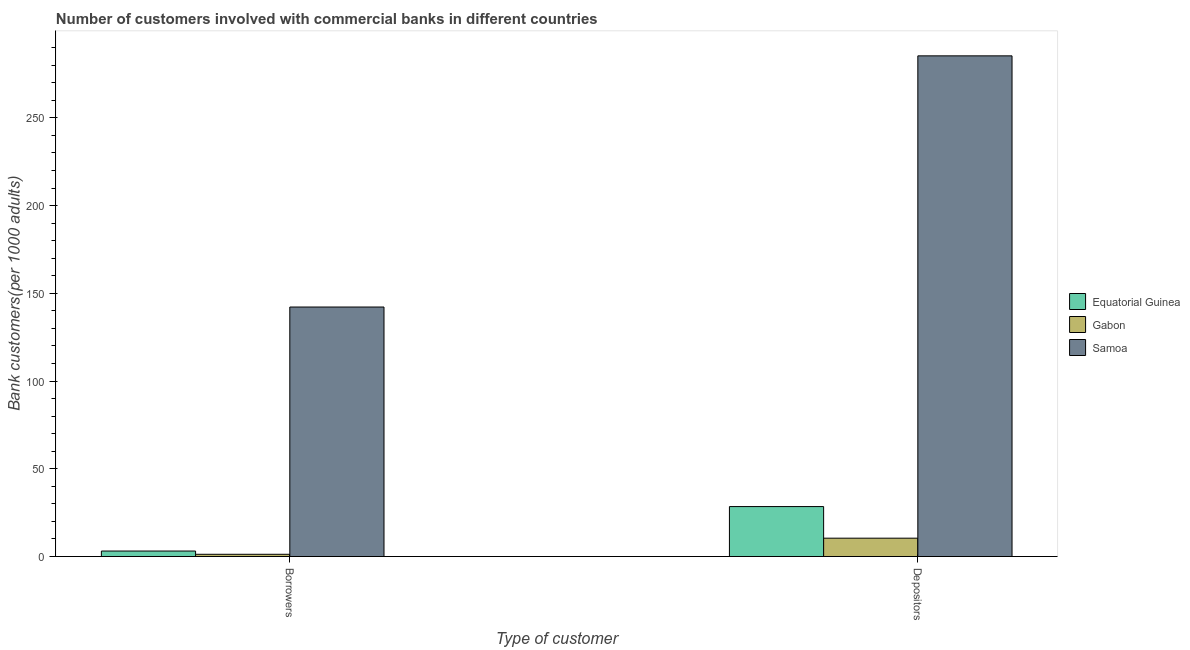Are the number of bars per tick equal to the number of legend labels?
Make the answer very short. Yes. How many bars are there on the 2nd tick from the right?
Your answer should be compact. 3. What is the label of the 1st group of bars from the left?
Ensure brevity in your answer.  Borrowers. What is the number of borrowers in Gabon?
Provide a succinct answer. 1.28. Across all countries, what is the maximum number of borrowers?
Your response must be concise. 142.19. Across all countries, what is the minimum number of borrowers?
Offer a very short reply. 1.28. In which country was the number of depositors maximum?
Your answer should be very brief. Samoa. In which country was the number of depositors minimum?
Offer a very short reply. Gabon. What is the total number of depositors in the graph?
Give a very brief answer. 324.25. What is the difference between the number of depositors in Equatorial Guinea and that in Samoa?
Make the answer very short. -256.85. What is the difference between the number of depositors in Gabon and the number of borrowers in Samoa?
Provide a succinct answer. -131.73. What is the average number of depositors per country?
Your answer should be very brief. 108.08. What is the difference between the number of borrowers and number of depositors in Samoa?
Your response must be concise. -143.13. What is the ratio of the number of depositors in Equatorial Guinea to that in Samoa?
Your response must be concise. 0.1. Is the number of borrowers in Gabon less than that in Samoa?
Offer a very short reply. Yes. What does the 1st bar from the left in Depositors represents?
Offer a very short reply. Equatorial Guinea. What does the 2nd bar from the right in Borrowers represents?
Offer a terse response. Gabon. How many bars are there?
Give a very brief answer. 6. Are all the bars in the graph horizontal?
Offer a terse response. No. How many countries are there in the graph?
Provide a short and direct response. 3. Are the values on the major ticks of Y-axis written in scientific E-notation?
Offer a very short reply. No. Does the graph contain any zero values?
Offer a terse response. No. Does the graph contain grids?
Keep it short and to the point. No. How many legend labels are there?
Keep it short and to the point. 3. How are the legend labels stacked?
Offer a very short reply. Vertical. What is the title of the graph?
Keep it short and to the point. Number of customers involved with commercial banks in different countries. What is the label or title of the X-axis?
Give a very brief answer. Type of customer. What is the label or title of the Y-axis?
Provide a succinct answer. Bank customers(per 1000 adults). What is the Bank customers(per 1000 adults) in Equatorial Guinea in Borrowers?
Make the answer very short. 3.13. What is the Bank customers(per 1000 adults) of Gabon in Borrowers?
Your answer should be very brief. 1.28. What is the Bank customers(per 1000 adults) in Samoa in Borrowers?
Your answer should be compact. 142.19. What is the Bank customers(per 1000 adults) in Equatorial Guinea in Depositors?
Your response must be concise. 28.47. What is the Bank customers(per 1000 adults) in Gabon in Depositors?
Give a very brief answer. 10.46. What is the Bank customers(per 1000 adults) in Samoa in Depositors?
Keep it short and to the point. 285.32. Across all Type of customer, what is the maximum Bank customers(per 1000 adults) of Equatorial Guinea?
Provide a short and direct response. 28.47. Across all Type of customer, what is the maximum Bank customers(per 1000 adults) of Gabon?
Provide a short and direct response. 10.46. Across all Type of customer, what is the maximum Bank customers(per 1000 adults) in Samoa?
Make the answer very short. 285.32. Across all Type of customer, what is the minimum Bank customers(per 1000 adults) in Equatorial Guinea?
Your answer should be very brief. 3.13. Across all Type of customer, what is the minimum Bank customers(per 1000 adults) in Gabon?
Make the answer very short. 1.28. Across all Type of customer, what is the minimum Bank customers(per 1000 adults) in Samoa?
Provide a succinct answer. 142.19. What is the total Bank customers(per 1000 adults) in Equatorial Guinea in the graph?
Offer a very short reply. 31.6. What is the total Bank customers(per 1000 adults) of Gabon in the graph?
Your answer should be very brief. 11.74. What is the total Bank customers(per 1000 adults) of Samoa in the graph?
Keep it short and to the point. 427.51. What is the difference between the Bank customers(per 1000 adults) of Equatorial Guinea in Borrowers and that in Depositors?
Offer a terse response. -25.34. What is the difference between the Bank customers(per 1000 adults) of Gabon in Borrowers and that in Depositors?
Ensure brevity in your answer.  -9.18. What is the difference between the Bank customers(per 1000 adults) of Samoa in Borrowers and that in Depositors?
Offer a terse response. -143.13. What is the difference between the Bank customers(per 1000 adults) of Equatorial Guinea in Borrowers and the Bank customers(per 1000 adults) of Gabon in Depositors?
Provide a short and direct response. -7.33. What is the difference between the Bank customers(per 1000 adults) of Equatorial Guinea in Borrowers and the Bank customers(per 1000 adults) of Samoa in Depositors?
Give a very brief answer. -282.19. What is the difference between the Bank customers(per 1000 adults) of Gabon in Borrowers and the Bank customers(per 1000 adults) of Samoa in Depositors?
Give a very brief answer. -284.04. What is the average Bank customers(per 1000 adults) of Equatorial Guinea per Type of customer?
Give a very brief answer. 15.8. What is the average Bank customers(per 1000 adults) of Gabon per Type of customer?
Offer a terse response. 5.87. What is the average Bank customers(per 1000 adults) of Samoa per Type of customer?
Your answer should be compact. 213.75. What is the difference between the Bank customers(per 1000 adults) of Equatorial Guinea and Bank customers(per 1000 adults) of Gabon in Borrowers?
Your answer should be very brief. 1.85. What is the difference between the Bank customers(per 1000 adults) in Equatorial Guinea and Bank customers(per 1000 adults) in Samoa in Borrowers?
Give a very brief answer. -139.06. What is the difference between the Bank customers(per 1000 adults) in Gabon and Bank customers(per 1000 adults) in Samoa in Borrowers?
Your response must be concise. -140.91. What is the difference between the Bank customers(per 1000 adults) of Equatorial Guinea and Bank customers(per 1000 adults) of Gabon in Depositors?
Give a very brief answer. 18.01. What is the difference between the Bank customers(per 1000 adults) in Equatorial Guinea and Bank customers(per 1000 adults) in Samoa in Depositors?
Give a very brief answer. -256.85. What is the difference between the Bank customers(per 1000 adults) of Gabon and Bank customers(per 1000 adults) of Samoa in Depositors?
Offer a terse response. -274.86. What is the ratio of the Bank customers(per 1000 adults) of Equatorial Guinea in Borrowers to that in Depositors?
Provide a succinct answer. 0.11. What is the ratio of the Bank customers(per 1000 adults) of Gabon in Borrowers to that in Depositors?
Your response must be concise. 0.12. What is the ratio of the Bank customers(per 1000 adults) in Samoa in Borrowers to that in Depositors?
Offer a terse response. 0.5. What is the difference between the highest and the second highest Bank customers(per 1000 adults) in Equatorial Guinea?
Provide a short and direct response. 25.34. What is the difference between the highest and the second highest Bank customers(per 1000 adults) in Gabon?
Your answer should be compact. 9.18. What is the difference between the highest and the second highest Bank customers(per 1000 adults) in Samoa?
Offer a terse response. 143.13. What is the difference between the highest and the lowest Bank customers(per 1000 adults) in Equatorial Guinea?
Offer a terse response. 25.34. What is the difference between the highest and the lowest Bank customers(per 1000 adults) in Gabon?
Offer a very short reply. 9.18. What is the difference between the highest and the lowest Bank customers(per 1000 adults) in Samoa?
Provide a succinct answer. 143.13. 